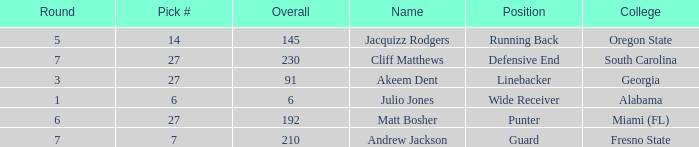Which highest pick number had Akeem Dent as a name and where the overall was less than 91? None. 